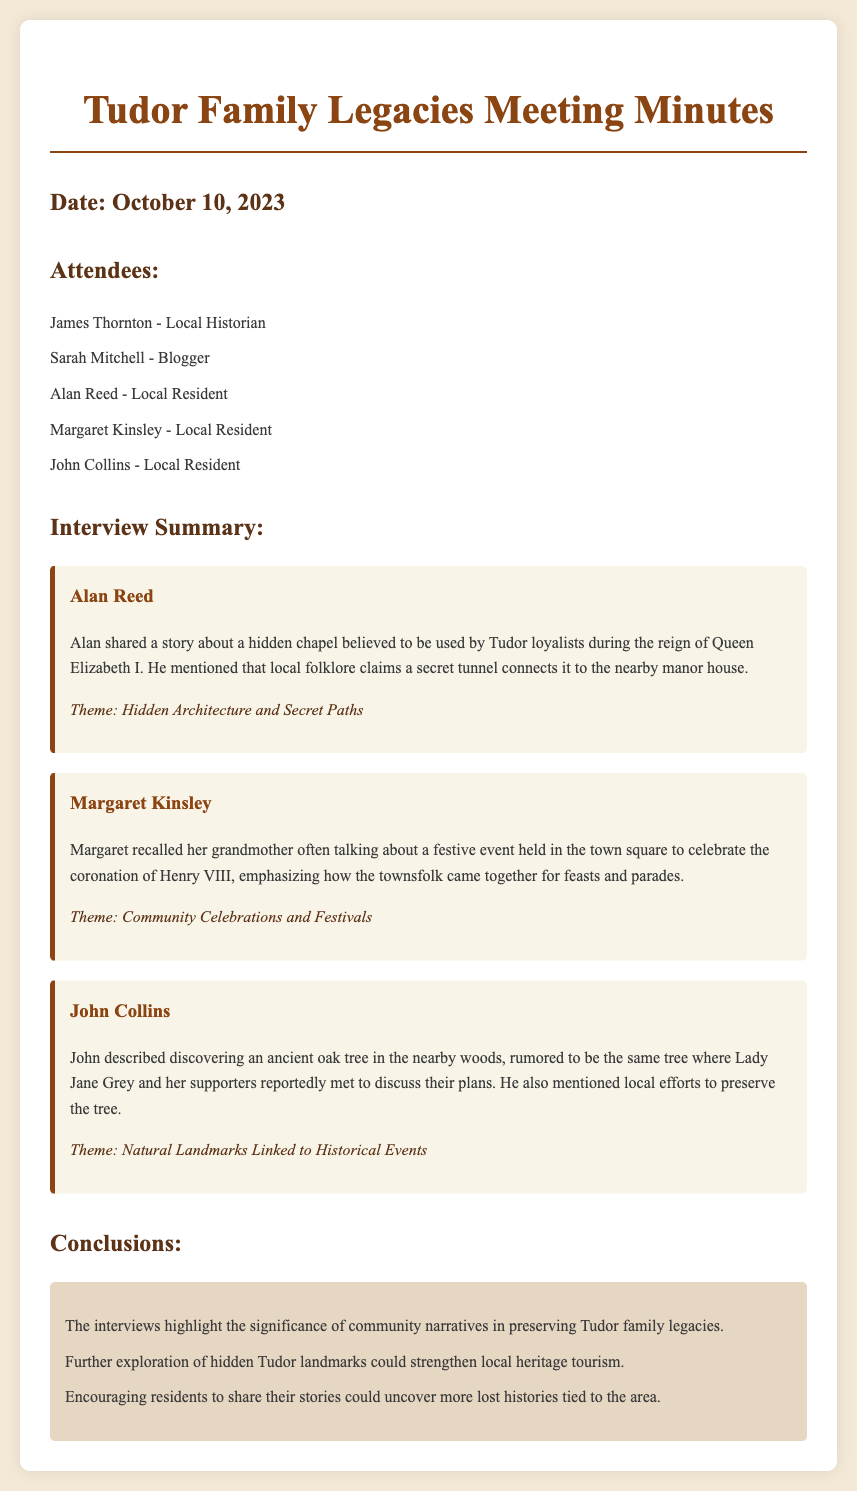What is the date of the meeting? The date of the meeting is explicitly stated in the document.
Answer: October 10, 2023 Who is the local historian present at the meeting? The document lists attendees, naming James Thornton as the local historian.
Answer: James Thornton What theme is associated with Alan Reed's story? The theme relates to Alan Reed's shared anecdote on hidden architecture and secret paths.
Answer: Hidden Architecture and Secret Paths What did Margaret Kinsley recall about community events? The document mentions a festive event held in the town square celebrating Henry VIII’s coronation.
Answer: Celebration of Henry VIII's coronation What was discovered by John Collins in the woods? John Collins described finding an ancient oak tree related to Lady Jane Grey's history.
Answer: An ancient oak tree What is a conclusion drawn from the interviews? The interviews' conclusions summarize insights into the narrative value and local heritage tourism potential.
Answer: Significance of community narratives What type of document is this? The document's title indicates that it consists of meeting minutes from a specific discussion.
Answer: Meeting minutes 